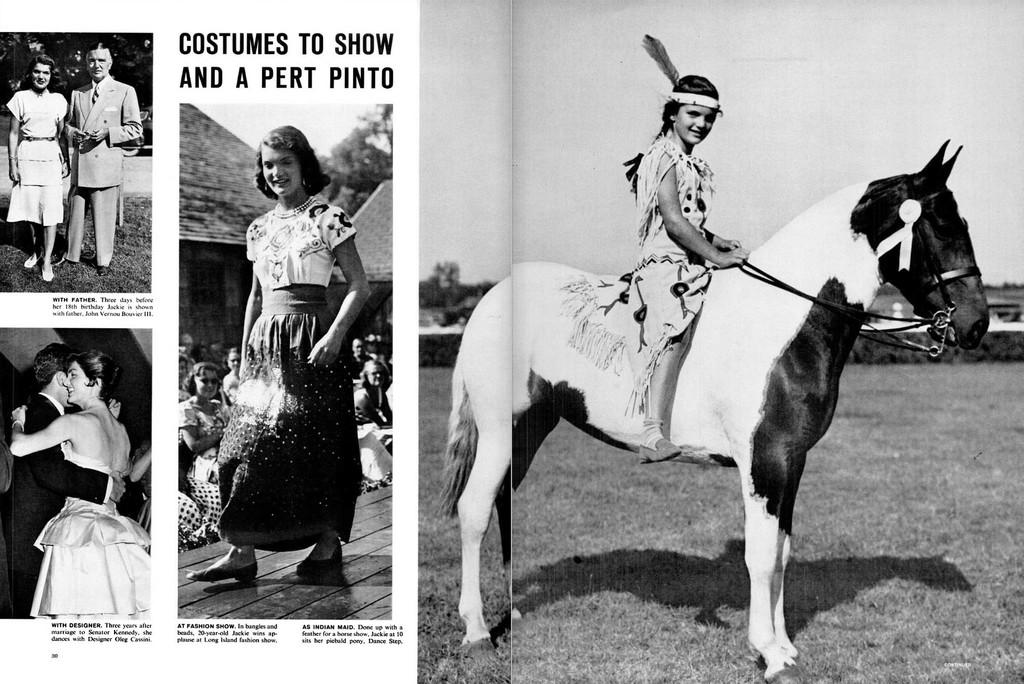What is the girl doing in the image? The girl is sitting on a horse. Are there any other people in the image? Yes, there are people standing nearby. What type of offer is the girl making to her sisters in the image? There is no mention of sisters or any offer being made in the image. 